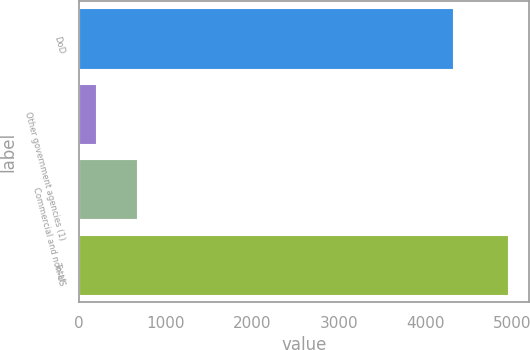Convert chart. <chart><loc_0><loc_0><loc_500><loc_500><bar_chart><fcel>DoD<fcel>Other government agencies (1)<fcel>Commercial and non-US<fcel>Total<nl><fcel>4318<fcel>194<fcel>669.4<fcel>4948<nl></chart> 